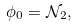Convert formula to latex. <formula><loc_0><loc_0><loc_500><loc_500>\phi _ { 0 } = \mathcal { N } _ { 2 } ,</formula> 